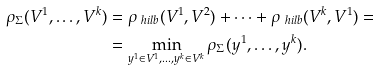Convert formula to latex. <formula><loc_0><loc_0><loc_500><loc_500>\rho _ { \Sigma } ( V ^ { 1 } , \dots , V ^ { k } ) & = \rho _ { \ h i l b } ( V ^ { 1 } , V ^ { 2 } ) + \dots + \rho _ { \ h i l b } ( V ^ { k } , V ^ { 1 } ) = \\ & = \min _ { y ^ { 1 } \in V ^ { 1 } , \dots , y ^ { k } \in V ^ { k } } \rho _ { \Sigma } ( y ^ { 1 } , \dots , y ^ { k } ) .</formula> 